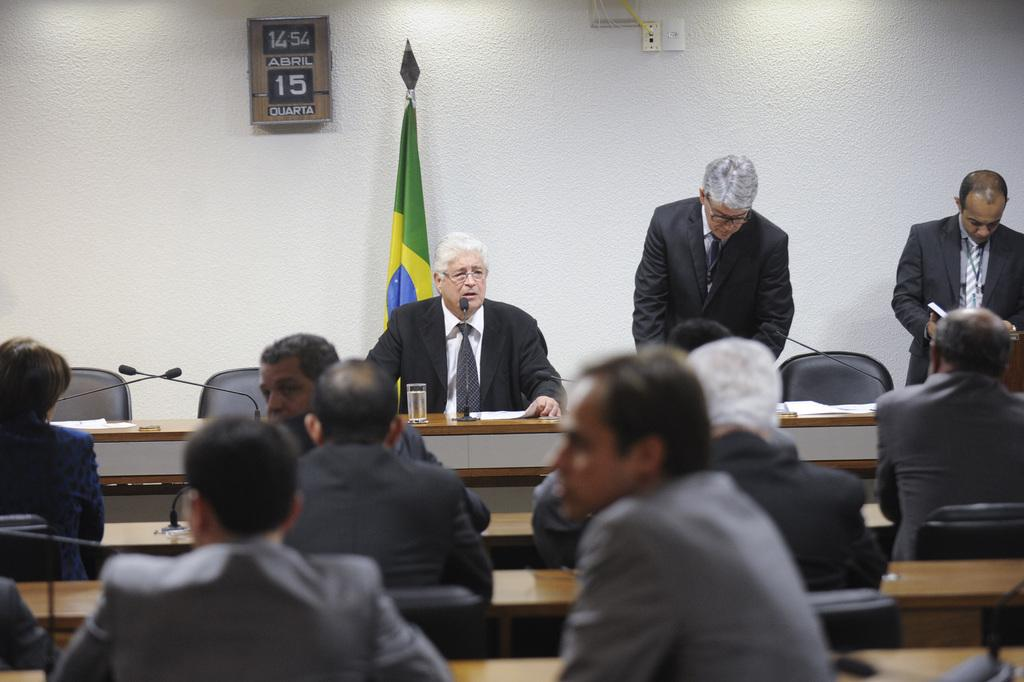What are the old men in the image doing? The old men are sitting in front of a table. What are the old men wearing? The old men are wearing black suits. What is behind the old men? There is a wall behind the old men. How many people are sitting in chairs in front of the old men? There are many people sitting in chairs in front of the old men. What are the people in front wearing? The people in front are wearing suits. What are the people in front doing? The people in front are staring in the same direction. How much salt is on the table in the image? There is no salt visible on the table in the image. What type of light source is illuminating the scene in the image? The image does not provide information about the light source; it only shows the people and their surroundings. 